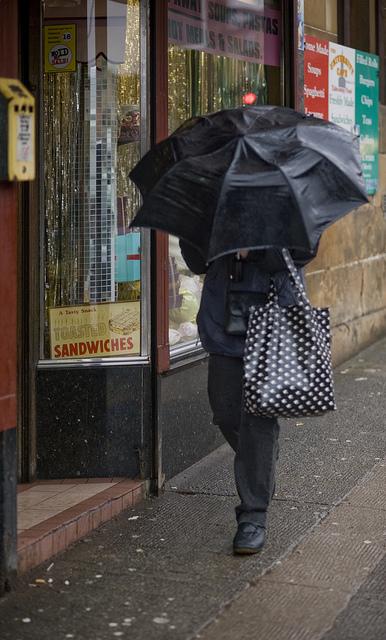What is written on the yellow sign in the window?
Answer briefly. Sandwiches. What is the design on the lady's tote bag?
Write a very short answer. Polka dots. Does the woman have a shopping bag?
Answer briefly. Yes. Is it raining outside?
Keep it brief. Yes. 